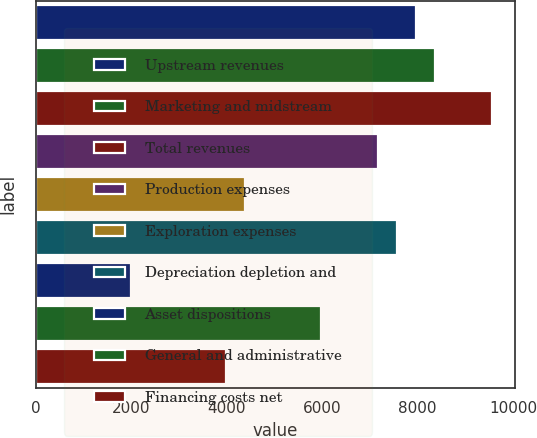Convert chart to OTSL. <chart><loc_0><loc_0><loc_500><loc_500><bar_chart><fcel>Upstream revenues<fcel>Marketing and midstream<fcel>Total revenues<fcel>Production expenses<fcel>Exploration expenses<fcel>Depreciation depletion and<fcel>Asset dispositions<fcel>General and administrative<fcel>Financing costs net<nl><fcel>7965.68<fcel>8363.94<fcel>9558.73<fcel>7169.15<fcel>4381.26<fcel>7567.41<fcel>1991.68<fcel>5974.34<fcel>3982.99<nl></chart> 